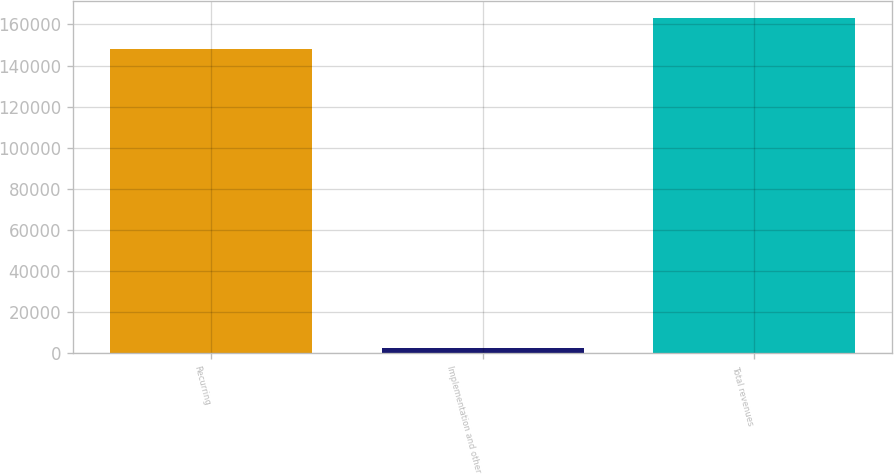<chart> <loc_0><loc_0><loc_500><loc_500><bar_chart><fcel>Recurring<fcel>Implementation and other<fcel>Total revenues<nl><fcel>148207<fcel>2722<fcel>163028<nl></chart> 